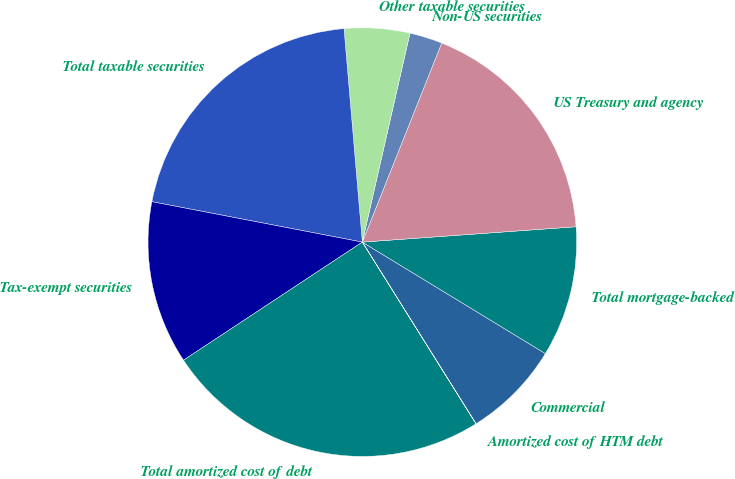Convert chart. <chart><loc_0><loc_0><loc_500><loc_500><pie_chart><fcel>Commercial<fcel>Total mortgage-backed<fcel>US Treasury and agency<fcel>Non-US securities<fcel>Other taxable securities<fcel>Total taxable securities<fcel>Tax-exempt securities<fcel>Total amortized cost of debt<fcel>Amortized cost of HTM debt<nl><fcel>7.39%<fcel>9.85%<fcel>17.82%<fcel>2.47%<fcel>4.93%<fcel>20.62%<fcel>12.31%<fcel>24.61%<fcel>0.01%<nl></chart> 